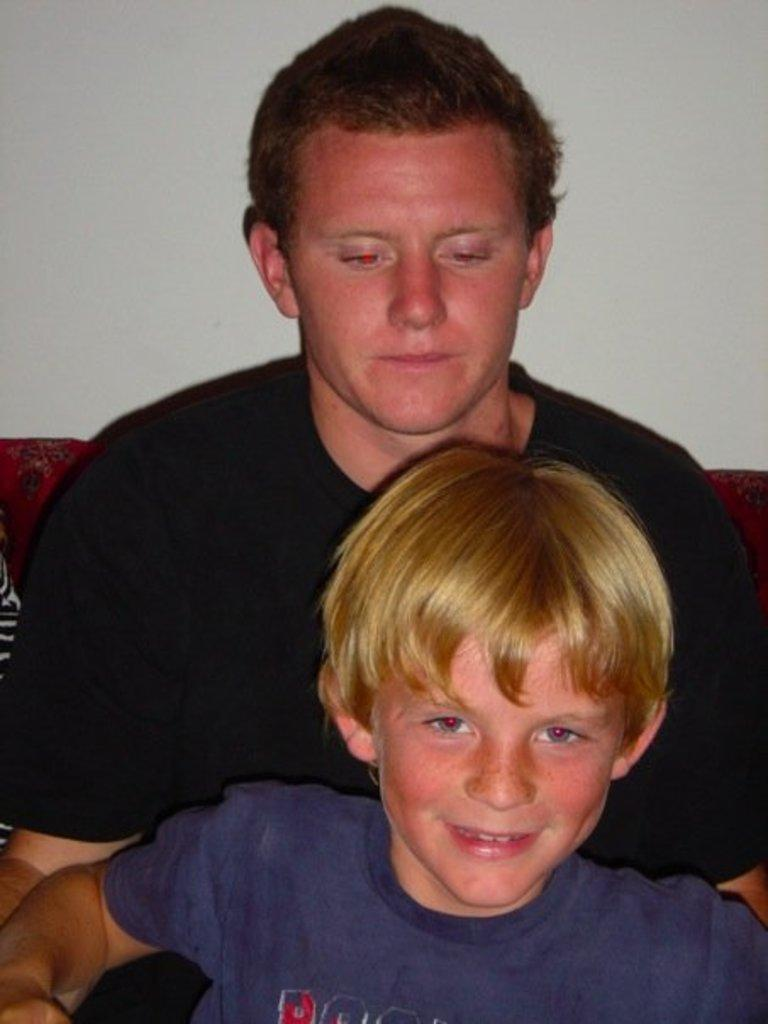Who is present in the image? There is a kid and a man in the image. What is the man wearing? The man is wearing a black t-shirt. What can be seen in the background of the image? There is a wall in the background of the image. How many bees can be seen on the man's feet in the image? There are no bees present in the image, and the man's feet are not visible. 